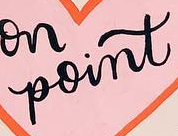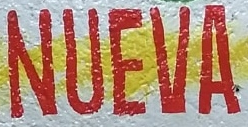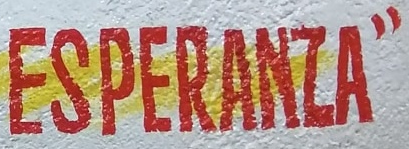Transcribe the words shown in these images in order, separated by a semicolon. point; NUEVA; ESPERANZA" 